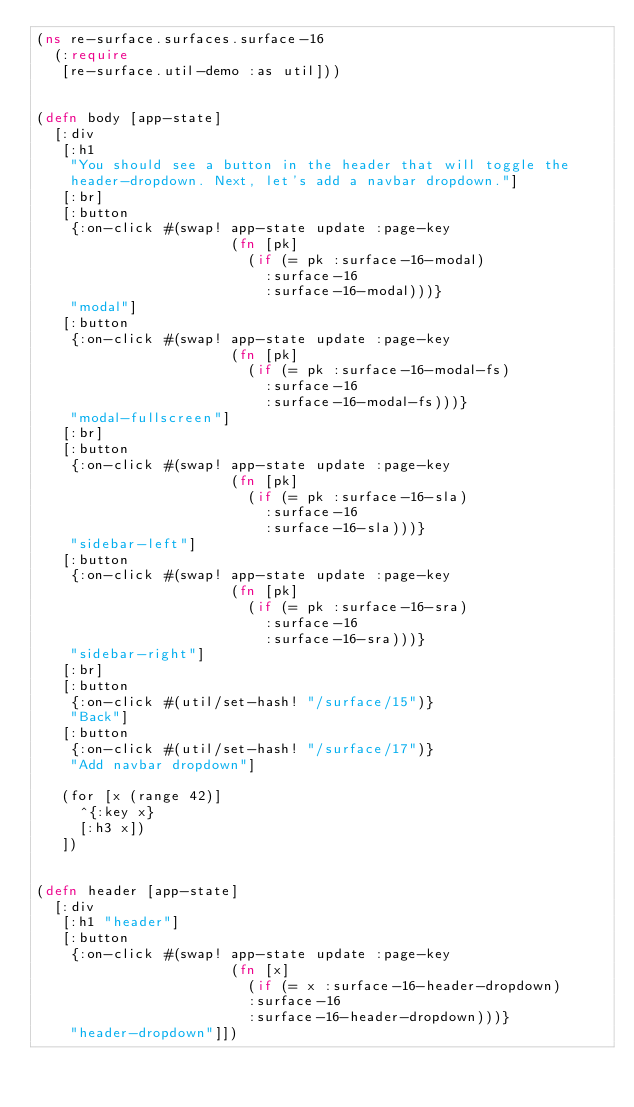<code> <loc_0><loc_0><loc_500><loc_500><_Clojure_>(ns re-surface.surfaces.surface-16
  (:require
   [re-surface.util-demo :as util]))


(defn body [app-state]
  [:div
   [:h1
    "You should see a button in the header that will toggle the
    header-dropdown. Next, let's add a navbar dropdown."]
   [:br]
   [:button
    {:on-click #(swap! app-state update :page-key
                       (fn [pk]
                         (if (= pk :surface-16-modal)
                           :surface-16
                           :surface-16-modal)))}
    "modal"]
   [:button
    {:on-click #(swap! app-state update :page-key
                       (fn [pk]
                         (if (= pk :surface-16-modal-fs)
                           :surface-16
                           :surface-16-modal-fs)))}
    "modal-fullscreen"]
   [:br]
   [:button
    {:on-click #(swap! app-state update :page-key
                       (fn [pk]
                         (if (= pk :surface-16-sla)
                           :surface-16
                           :surface-16-sla)))}
    "sidebar-left"]
   [:button
    {:on-click #(swap! app-state update :page-key
                       (fn [pk]
                         (if (= pk :surface-16-sra)
                           :surface-16
                           :surface-16-sra)))}
    "sidebar-right"]
   [:br]
   [:button
    {:on-click #(util/set-hash! "/surface/15")}
    "Back"]
   [:button
    {:on-click #(util/set-hash! "/surface/17")}
    "Add navbar dropdown"]

   (for [x (range 42)]
     ^{:key x}
     [:h3 x])
   ])


(defn header [app-state]
  [:div
   [:h1 "header"]
   [:button
    {:on-click #(swap! app-state update :page-key
                       (fn [x]
                         (if (= x :surface-16-header-dropdown)
                         :surface-16
                         :surface-16-header-dropdown)))}
    "header-dropdown"]])
</code> 